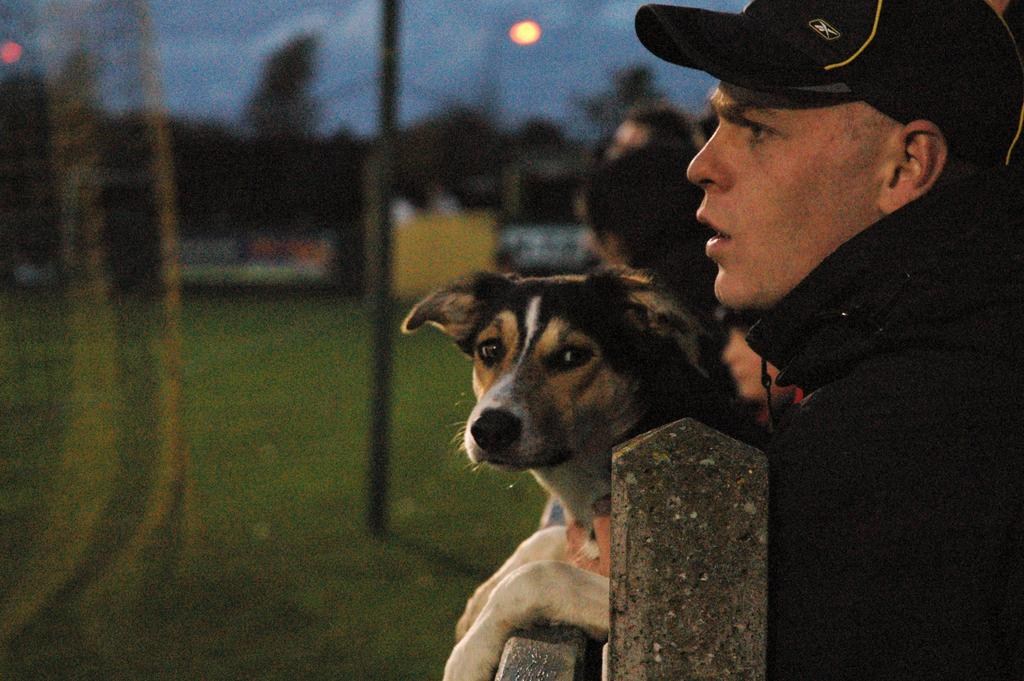Who is present in the image? There is a man in the image. What other living creature is in the image? There is a dog in the image. What type of headwear is the man wearing? The man is wearing a cap. Where is the wax sculpture of the man and dog located in the image? There is no wax sculpture present in the image; it features a real man and a real dog. 